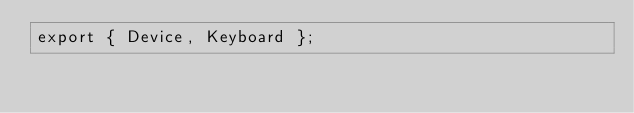Convert code to text. <code><loc_0><loc_0><loc_500><loc_500><_JavaScript_>export { Device, Keyboard };
</code> 